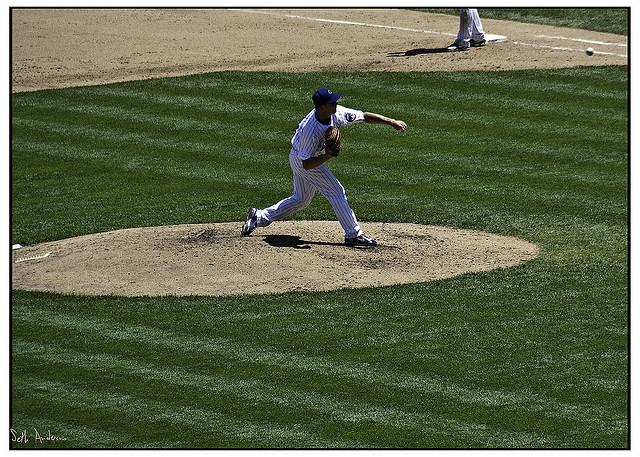What position is this man playing?
Write a very short answer. Pitcher. Is the lawn well manicured?
Write a very short answer. Yes. What sport is being played in this picture?
Give a very brief answer. Baseball. 